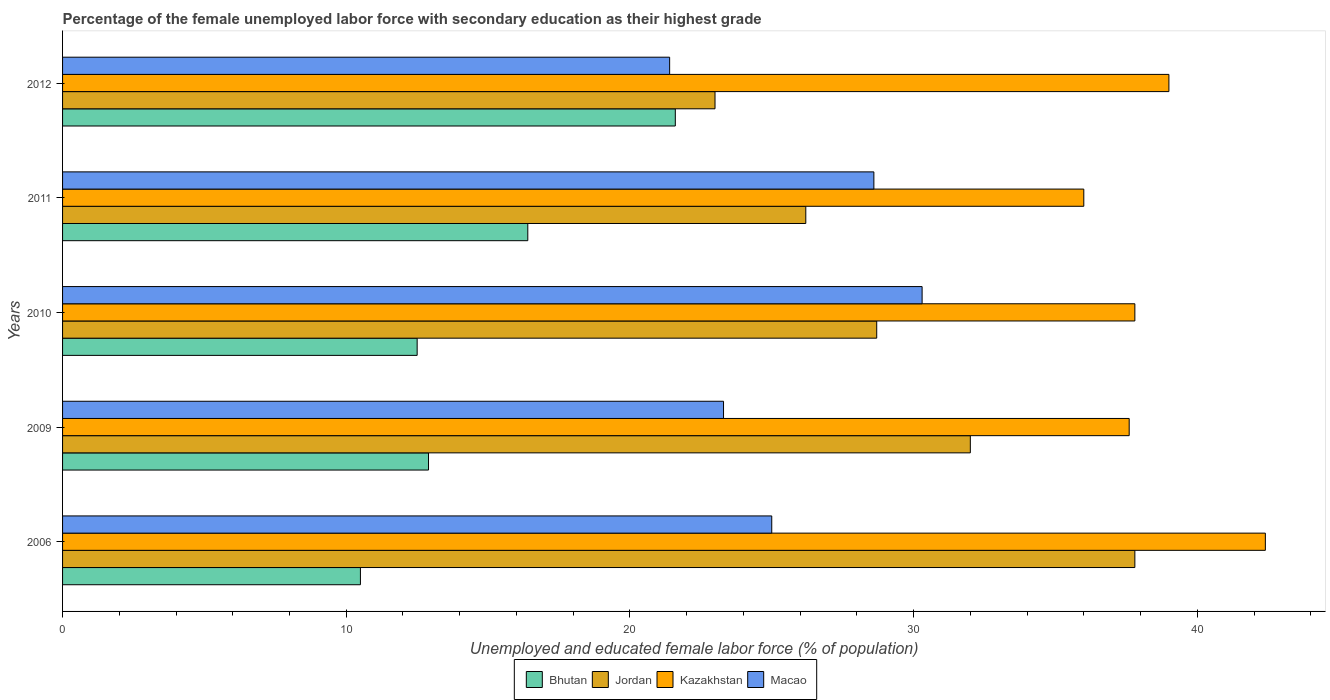How many different coloured bars are there?
Your response must be concise. 4. Are the number of bars on each tick of the Y-axis equal?
Provide a succinct answer. Yes. How many bars are there on the 2nd tick from the bottom?
Ensure brevity in your answer.  4. What is the percentage of the unemployed female labor force with secondary education in Bhutan in 2009?
Keep it short and to the point. 12.9. Across all years, what is the maximum percentage of the unemployed female labor force with secondary education in Kazakhstan?
Give a very brief answer. 42.4. Across all years, what is the minimum percentage of the unemployed female labor force with secondary education in Jordan?
Your answer should be compact. 23. In which year was the percentage of the unemployed female labor force with secondary education in Bhutan maximum?
Your response must be concise. 2012. What is the total percentage of the unemployed female labor force with secondary education in Kazakhstan in the graph?
Offer a very short reply. 192.8. What is the difference between the percentage of the unemployed female labor force with secondary education in Kazakhstan in 2006 and that in 2010?
Give a very brief answer. 4.6. What is the difference between the percentage of the unemployed female labor force with secondary education in Bhutan in 2006 and the percentage of the unemployed female labor force with secondary education in Jordan in 2011?
Your response must be concise. -15.7. What is the average percentage of the unemployed female labor force with secondary education in Bhutan per year?
Ensure brevity in your answer.  14.78. In how many years, is the percentage of the unemployed female labor force with secondary education in Jordan greater than 18 %?
Keep it short and to the point. 5. What is the ratio of the percentage of the unemployed female labor force with secondary education in Kazakhstan in 2006 to that in 2012?
Offer a very short reply. 1.09. Is the difference between the percentage of the unemployed female labor force with secondary education in Macao in 2010 and 2012 greater than the difference between the percentage of the unemployed female labor force with secondary education in Bhutan in 2010 and 2012?
Your answer should be compact. Yes. What is the difference between the highest and the second highest percentage of the unemployed female labor force with secondary education in Kazakhstan?
Give a very brief answer. 3.4. What is the difference between the highest and the lowest percentage of the unemployed female labor force with secondary education in Bhutan?
Provide a short and direct response. 11.1. What does the 3rd bar from the top in 2009 represents?
Offer a terse response. Jordan. What does the 3rd bar from the bottom in 2012 represents?
Ensure brevity in your answer.  Kazakhstan. Is it the case that in every year, the sum of the percentage of the unemployed female labor force with secondary education in Bhutan and percentage of the unemployed female labor force with secondary education in Macao is greater than the percentage of the unemployed female labor force with secondary education in Kazakhstan?
Keep it short and to the point. No. How many bars are there?
Offer a terse response. 20. Are all the bars in the graph horizontal?
Your answer should be compact. Yes. What is the difference between two consecutive major ticks on the X-axis?
Keep it short and to the point. 10. Does the graph contain any zero values?
Provide a succinct answer. No. How many legend labels are there?
Your response must be concise. 4. What is the title of the graph?
Ensure brevity in your answer.  Percentage of the female unemployed labor force with secondary education as their highest grade. What is the label or title of the X-axis?
Provide a succinct answer. Unemployed and educated female labor force (% of population). What is the Unemployed and educated female labor force (% of population) in Bhutan in 2006?
Keep it short and to the point. 10.5. What is the Unemployed and educated female labor force (% of population) of Jordan in 2006?
Offer a very short reply. 37.8. What is the Unemployed and educated female labor force (% of population) of Kazakhstan in 2006?
Ensure brevity in your answer.  42.4. What is the Unemployed and educated female labor force (% of population) of Macao in 2006?
Keep it short and to the point. 25. What is the Unemployed and educated female labor force (% of population) in Bhutan in 2009?
Your answer should be very brief. 12.9. What is the Unemployed and educated female labor force (% of population) in Jordan in 2009?
Your response must be concise. 32. What is the Unemployed and educated female labor force (% of population) in Kazakhstan in 2009?
Give a very brief answer. 37.6. What is the Unemployed and educated female labor force (% of population) of Macao in 2009?
Your answer should be very brief. 23.3. What is the Unemployed and educated female labor force (% of population) in Jordan in 2010?
Provide a succinct answer. 28.7. What is the Unemployed and educated female labor force (% of population) in Kazakhstan in 2010?
Make the answer very short. 37.8. What is the Unemployed and educated female labor force (% of population) of Macao in 2010?
Make the answer very short. 30.3. What is the Unemployed and educated female labor force (% of population) of Bhutan in 2011?
Offer a terse response. 16.4. What is the Unemployed and educated female labor force (% of population) of Jordan in 2011?
Give a very brief answer. 26.2. What is the Unemployed and educated female labor force (% of population) of Kazakhstan in 2011?
Make the answer very short. 36. What is the Unemployed and educated female labor force (% of population) of Macao in 2011?
Offer a terse response. 28.6. What is the Unemployed and educated female labor force (% of population) in Bhutan in 2012?
Provide a succinct answer. 21.6. What is the Unemployed and educated female labor force (% of population) of Macao in 2012?
Give a very brief answer. 21.4. Across all years, what is the maximum Unemployed and educated female labor force (% of population) of Bhutan?
Your answer should be compact. 21.6. Across all years, what is the maximum Unemployed and educated female labor force (% of population) in Jordan?
Make the answer very short. 37.8. Across all years, what is the maximum Unemployed and educated female labor force (% of population) in Kazakhstan?
Keep it short and to the point. 42.4. Across all years, what is the maximum Unemployed and educated female labor force (% of population) of Macao?
Provide a short and direct response. 30.3. Across all years, what is the minimum Unemployed and educated female labor force (% of population) in Jordan?
Ensure brevity in your answer.  23. Across all years, what is the minimum Unemployed and educated female labor force (% of population) of Macao?
Your answer should be compact. 21.4. What is the total Unemployed and educated female labor force (% of population) of Bhutan in the graph?
Provide a succinct answer. 73.9. What is the total Unemployed and educated female labor force (% of population) of Jordan in the graph?
Ensure brevity in your answer.  147.7. What is the total Unemployed and educated female labor force (% of population) in Kazakhstan in the graph?
Give a very brief answer. 192.8. What is the total Unemployed and educated female labor force (% of population) of Macao in the graph?
Make the answer very short. 128.6. What is the difference between the Unemployed and educated female labor force (% of population) of Bhutan in 2006 and that in 2009?
Your answer should be compact. -2.4. What is the difference between the Unemployed and educated female labor force (% of population) in Macao in 2006 and that in 2009?
Provide a short and direct response. 1.7. What is the difference between the Unemployed and educated female labor force (% of population) of Macao in 2006 and that in 2011?
Provide a short and direct response. -3.6. What is the difference between the Unemployed and educated female labor force (% of population) of Bhutan in 2006 and that in 2012?
Keep it short and to the point. -11.1. What is the difference between the Unemployed and educated female labor force (% of population) of Kazakhstan in 2006 and that in 2012?
Give a very brief answer. 3.4. What is the difference between the Unemployed and educated female labor force (% of population) in Macao in 2006 and that in 2012?
Ensure brevity in your answer.  3.6. What is the difference between the Unemployed and educated female labor force (% of population) of Jordan in 2009 and that in 2010?
Make the answer very short. 3.3. What is the difference between the Unemployed and educated female labor force (% of population) in Kazakhstan in 2009 and that in 2010?
Your answer should be compact. -0.2. What is the difference between the Unemployed and educated female labor force (% of population) in Jordan in 2009 and that in 2011?
Your answer should be compact. 5.8. What is the difference between the Unemployed and educated female labor force (% of population) of Macao in 2009 and that in 2011?
Make the answer very short. -5.3. What is the difference between the Unemployed and educated female labor force (% of population) of Kazakhstan in 2009 and that in 2012?
Offer a terse response. -1.4. What is the difference between the Unemployed and educated female labor force (% of population) of Macao in 2009 and that in 2012?
Ensure brevity in your answer.  1.9. What is the difference between the Unemployed and educated female labor force (% of population) in Jordan in 2010 and that in 2011?
Your answer should be compact. 2.5. What is the difference between the Unemployed and educated female labor force (% of population) of Kazakhstan in 2010 and that in 2011?
Offer a very short reply. 1.8. What is the difference between the Unemployed and educated female labor force (% of population) in Macao in 2010 and that in 2011?
Give a very brief answer. 1.7. What is the difference between the Unemployed and educated female labor force (% of population) of Macao in 2010 and that in 2012?
Your answer should be very brief. 8.9. What is the difference between the Unemployed and educated female labor force (% of population) of Jordan in 2011 and that in 2012?
Give a very brief answer. 3.2. What is the difference between the Unemployed and educated female labor force (% of population) in Macao in 2011 and that in 2012?
Keep it short and to the point. 7.2. What is the difference between the Unemployed and educated female labor force (% of population) in Bhutan in 2006 and the Unemployed and educated female labor force (% of population) in Jordan in 2009?
Provide a succinct answer. -21.5. What is the difference between the Unemployed and educated female labor force (% of population) in Bhutan in 2006 and the Unemployed and educated female labor force (% of population) in Kazakhstan in 2009?
Keep it short and to the point. -27.1. What is the difference between the Unemployed and educated female labor force (% of population) in Bhutan in 2006 and the Unemployed and educated female labor force (% of population) in Macao in 2009?
Your response must be concise. -12.8. What is the difference between the Unemployed and educated female labor force (% of population) in Jordan in 2006 and the Unemployed and educated female labor force (% of population) in Kazakhstan in 2009?
Ensure brevity in your answer.  0.2. What is the difference between the Unemployed and educated female labor force (% of population) in Jordan in 2006 and the Unemployed and educated female labor force (% of population) in Macao in 2009?
Your response must be concise. 14.5. What is the difference between the Unemployed and educated female labor force (% of population) in Bhutan in 2006 and the Unemployed and educated female labor force (% of population) in Jordan in 2010?
Keep it short and to the point. -18.2. What is the difference between the Unemployed and educated female labor force (% of population) in Bhutan in 2006 and the Unemployed and educated female labor force (% of population) in Kazakhstan in 2010?
Keep it short and to the point. -27.3. What is the difference between the Unemployed and educated female labor force (% of population) of Bhutan in 2006 and the Unemployed and educated female labor force (% of population) of Macao in 2010?
Your answer should be very brief. -19.8. What is the difference between the Unemployed and educated female labor force (% of population) in Jordan in 2006 and the Unemployed and educated female labor force (% of population) in Kazakhstan in 2010?
Offer a terse response. 0. What is the difference between the Unemployed and educated female labor force (% of population) of Jordan in 2006 and the Unemployed and educated female labor force (% of population) of Macao in 2010?
Your response must be concise. 7.5. What is the difference between the Unemployed and educated female labor force (% of population) of Kazakhstan in 2006 and the Unemployed and educated female labor force (% of population) of Macao in 2010?
Your answer should be compact. 12.1. What is the difference between the Unemployed and educated female labor force (% of population) in Bhutan in 2006 and the Unemployed and educated female labor force (% of population) in Jordan in 2011?
Your answer should be compact. -15.7. What is the difference between the Unemployed and educated female labor force (% of population) in Bhutan in 2006 and the Unemployed and educated female labor force (% of population) in Kazakhstan in 2011?
Your answer should be compact. -25.5. What is the difference between the Unemployed and educated female labor force (% of population) in Bhutan in 2006 and the Unemployed and educated female labor force (% of population) in Macao in 2011?
Provide a short and direct response. -18.1. What is the difference between the Unemployed and educated female labor force (% of population) in Jordan in 2006 and the Unemployed and educated female labor force (% of population) in Kazakhstan in 2011?
Provide a succinct answer. 1.8. What is the difference between the Unemployed and educated female labor force (% of population) of Jordan in 2006 and the Unemployed and educated female labor force (% of population) of Macao in 2011?
Offer a terse response. 9.2. What is the difference between the Unemployed and educated female labor force (% of population) of Bhutan in 2006 and the Unemployed and educated female labor force (% of population) of Jordan in 2012?
Keep it short and to the point. -12.5. What is the difference between the Unemployed and educated female labor force (% of population) in Bhutan in 2006 and the Unemployed and educated female labor force (% of population) in Kazakhstan in 2012?
Your answer should be very brief. -28.5. What is the difference between the Unemployed and educated female labor force (% of population) of Jordan in 2006 and the Unemployed and educated female labor force (% of population) of Kazakhstan in 2012?
Your answer should be very brief. -1.2. What is the difference between the Unemployed and educated female labor force (% of population) in Kazakhstan in 2006 and the Unemployed and educated female labor force (% of population) in Macao in 2012?
Provide a short and direct response. 21. What is the difference between the Unemployed and educated female labor force (% of population) in Bhutan in 2009 and the Unemployed and educated female labor force (% of population) in Jordan in 2010?
Offer a very short reply. -15.8. What is the difference between the Unemployed and educated female labor force (% of population) in Bhutan in 2009 and the Unemployed and educated female labor force (% of population) in Kazakhstan in 2010?
Ensure brevity in your answer.  -24.9. What is the difference between the Unemployed and educated female labor force (% of population) of Bhutan in 2009 and the Unemployed and educated female labor force (% of population) of Macao in 2010?
Ensure brevity in your answer.  -17.4. What is the difference between the Unemployed and educated female labor force (% of population) in Jordan in 2009 and the Unemployed and educated female labor force (% of population) in Kazakhstan in 2010?
Give a very brief answer. -5.8. What is the difference between the Unemployed and educated female labor force (% of population) in Jordan in 2009 and the Unemployed and educated female labor force (% of population) in Macao in 2010?
Make the answer very short. 1.7. What is the difference between the Unemployed and educated female labor force (% of population) in Bhutan in 2009 and the Unemployed and educated female labor force (% of population) in Kazakhstan in 2011?
Offer a terse response. -23.1. What is the difference between the Unemployed and educated female labor force (% of population) of Bhutan in 2009 and the Unemployed and educated female labor force (% of population) of Macao in 2011?
Offer a terse response. -15.7. What is the difference between the Unemployed and educated female labor force (% of population) of Jordan in 2009 and the Unemployed and educated female labor force (% of population) of Macao in 2011?
Offer a terse response. 3.4. What is the difference between the Unemployed and educated female labor force (% of population) in Bhutan in 2009 and the Unemployed and educated female labor force (% of population) in Jordan in 2012?
Your answer should be compact. -10.1. What is the difference between the Unemployed and educated female labor force (% of population) of Bhutan in 2009 and the Unemployed and educated female labor force (% of population) of Kazakhstan in 2012?
Keep it short and to the point. -26.1. What is the difference between the Unemployed and educated female labor force (% of population) of Jordan in 2009 and the Unemployed and educated female labor force (% of population) of Kazakhstan in 2012?
Offer a very short reply. -7. What is the difference between the Unemployed and educated female labor force (% of population) of Kazakhstan in 2009 and the Unemployed and educated female labor force (% of population) of Macao in 2012?
Give a very brief answer. 16.2. What is the difference between the Unemployed and educated female labor force (% of population) in Bhutan in 2010 and the Unemployed and educated female labor force (% of population) in Jordan in 2011?
Offer a terse response. -13.7. What is the difference between the Unemployed and educated female labor force (% of population) in Bhutan in 2010 and the Unemployed and educated female labor force (% of population) in Kazakhstan in 2011?
Offer a very short reply. -23.5. What is the difference between the Unemployed and educated female labor force (% of population) in Bhutan in 2010 and the Unemployed and educated female labor force (% of population) in Macao in 2011?
Give a very brief answer. -16.1. What is the difference between the Unemployed and educated female labor force (% of population) in Kazakhstan in 2010 and the Unemployed and educated female labor force (% of population) in Macao in 2011?
Your response must be concise. 9.2. What is the difference between the Unemployed and educated female labor force (% of population) in Bhutan in 2010 and the Unemployed and educated female labor force (% of population) in Kazakhstan in 2012?
Provide a short and direct response. -26.5. What is the difference between the Unemployed and educated female labor force (% of population) of Bhutan in 2011 and the Unemployed and educated female labor force (% of population) of Jordan in 2012?
Offer a very short reply. -6.6. What is the difference between the Unemployed and educated female labor force (% of population) in Bhutan in 2011 and the Unemployed and educated female labor force (% of population) in Kazakhstan in 2012?
Your answer should be compact. -22.6. What is the difference between the Unemployed and educated female labor force (% of population) in Bhutan in 2011 and the Unemployed and educated female labor force (% of population) in Macao in 2012?
Your response must be concise. -5. What is the difference between the Unemployed and educated female labor force (% of population) in Jordan in 2011 and the Unemployed and educated female labor force (% of population) in Macao in 2012?
Your answer should be compact. 4.8. What is the average Unemployed and educated female labor force (% of population) in Bhutan per year?
Give a very brief answer. 14.78. What is the average Unemployed and educated female labor force (% of population) in Jordan per year?
Keep it short and to the point. 29.54. What is the average Unemployed and educated female labor force (% of population) in Kazakhstan per year?
Provide a short and direct response. 38.56. What is the average Unemployed and educated female labor force (% of population) in Macao per year?
Offer a terse response. 25.72. In the year 2006, what is the difference between the Unemployed and educated female labor force (% of population) in Bhutan and Unemployed and educated female labor force (% of population) in Jordan?
Your answer should be very brief. -27.3. In the year 2006, what is the difference between the Unemployed and educated female labor force (% of population) of Bhutan and Unemployed and educated female labor force (% of population) of Kazakhstan?
Give a very brief answer. -31.9. In the year 2006, what is the difference between the Unemployed and educated female labor force (% of population) of Bhutan and Unemployed and educated female labor force (% of population) of Macao?
Ensure brevity in your answer.  -14.5. In the year 2006, what is the difference between the Unemployed and educated female labor force (% of population) in Jordan and Unemployed and educated female labor force (% of population) in Macao?
Your answer should be compact. 12.8. In the year 2006, what is the difference between the Unemployed and educated female labor force (% of population) in Kazakhstan and Unemployed and educated female labor force (% of population) in Macao?
Offer a terse response. 17.4. In the year 2009, what is the difference between the Unemployed and educated female labor force (% of population) in Bhutan and Unemployed and educated female labor force (% of population) in Jordan?
Provide a succinct answer. -19.1. In the year 2009, what is the difference between the Unemployed and educated female labor force (% of population) in Bhutan and Unemployed and educated female labor force (% of population) in Kazakhstan?
Your answer should be very brief. -24.7. In the year 2009, what is the difference between the Unemployed and educated female labor force (% of population) of Jordan and Unemployed and educated female labor force (% of population) of Macao?
Your response must be concise. 8.7. In the year 2010, what is the difference between the Unemployed and educated female labor force (% of population) in Bhutan and Unemployed and educated female labor force (% of population) in Jordan?
Give a very brief answer. -16.2. In the year 2010, what is the difference between the Unemployed and educated female labor force (% of population) in Bhutan and Unemployed and educated female labor force (% of population) in Kazakhstan?
Offer a terse response. -25.3. In the year 2010, what is the difference between the Unemployed and educated female labor force (% of population) in Bhutan and Unemployed and educated female labor force (% of population) in Macao?
Your response must be concise. -17.8. In the year 2010, what is the difference between the Unemployed and educated female labor force (% of population) in Jordan and Unemployed and educated female labor force (% of population) in Kazakhstan?
Your answer should be very brief. -9.1. In the year 2010, what is the difference between the Unemployed and educated female labor force (% of population) of Jordan and Unemployed and educated female labor force (% of population) of Macao?
Ensure brevity in your answer.  -1.6. In the year 2011, what is the difference between the Unemployed and educated female labor force (% of population) in Bhutan and Unemployed and educated female labor force (% of population) in Jordan?
Provide a short and direct response. -9.8. In the year 2011, what is the difference between the Unemployed and educated female labor force (% of population) of Bhutan and Unemployed and educated female labor force (% of population) of Kazakhstan?
Offer a very short reply. -19.6. In the year 2011, what is the difference between the Unemployed and educated female labor force (% of population) in Jordan and Unemployed and educated female labor force (% of population) in Macao?
Your response must be concise. -2.4. In the year 2012, what is the difference between the Unemployed and educated female labor force (% of population) in Bhutan and Unemployed and educated female labor force (% of population) in Jordan?
Ensure brevity in your answer.  -1.4. In the year 2012, what is the difference between the Unemployed and educated female labor force (% of population) of Bhutan and Unemployed and educated female labor force (% of population) of Kazakhstan?
Your answer should be compact. -17.4. In the year 2012, what is the difference between the Unemployed and educated female labor force (% of population) in Bhutan and Unemployed and educated female labor force (% of population) in Macao?
Provide a short and direct response. 0.2. In the year 2012, what is the difference between the Unemployed and educated female labor force (% of population) in Jordan and Unemployed and educated female labor force (% of population) in Kazakhstan?
Your answer should be compact. -16. In the year 2012, what is the difference between the Unemployed and educated female labor force (% of population) of Jordan and Unemployed and educated female labor force (% of population) of Macao?
Provide a short and direct response. 1.6. In the year 2012, what is the difference between the Unemployed and educated female labor force (% of population) of Kazakhstan and Unemployed and educated female labor force (% of population) of Macao?
Offer a very short reply. 17.6. What is the ratio of the Unemployed and educated female labor force (% of population) of Bhutan in 2006 to that in 2009?
Your response must be concise. 0.81. What is the ratio of the Unemployed and educated female labor force (% of population) of Jordan in 2006 to that in 2009?
Give a very brief answer. 1.18. What is the ratio of the Unemployed and educated female labor force (% of population) in Kazakhstan in 2006 to that in 2009?
Offer a terse response. 1.13. What is the ratio of the Unemployed and educated female labor force (% of population) in Macao in 2006 to that in 2009?
Provide a short and direct response. 1.07. What is the ratio of the Unemployed and educated female labor force (% of population) of Bhutan in 2006 to that in 2010?
Keep it short and to the point. 0.84. What is the ratio of the Unemployed and educated female labor force (% of population) in Jordan in 2006 to that in 2010?
Your response must be concise. 1.32. What is the ratio of the Unemployed and educated female labor force (% of population) in Kazakhstan in 2006 to that in 2010?
Ensure brevity in your answer.  1.12. What is the ratio of the Unemployed and educated female labor force (% of population) of Macao in 2006 to that in 2010?
Your answer should be compact. 0.83. What is the ratio of the Unemployed and educated female labor force (% of population) in Bhutan in 2006 to that in 2011?
Your answer should be compact. 0.64. What is the ratio of the Unemployed and educated female labor force (% of population) of Jordan in 2006 to that in 2011?
Your answer should be very brief. 1.44. What is the ratio of the Unemployed and educated female labor force (% of population) of Kazakhstan in 2006 to that in 2011?
Offer a very short reply. 1.18. What is the ratio of the Unemployed and educated female labor force (% of population) of Macao in 2006 to that in 2011?
Keep it short and to the point. 0.87. What is the ratio of the Unemployed and educated female labor force (% of population) of Bhutan in 2006 to that in 2012?
Offer a terse response. 0.49. What is the ratio of the Unemployed and educated female labor force (% of population) in Jordan in 2006 to that in 2012?
Your answer should be compact. 1.64. What is the ratio of the Unemployed and educated female labor force (% of population) of Kazakhstan in 2006 to that in 2012?
Your answer should be compact. 1.09. What is the ratio of the Unemployed and educated female labor force (% of population) in Macao in 2006 to that in 2012?
Offer a terse response. 1.17. What is the ratio of the Unemployed and educated female labor force (% of population) in Bhutan in 2009 to that in 2010?
Your answer should be compact. 1.03. What is the ratio of the Unemployed and educated female labor force (% of population) of Jordan in 2009 to that in 2010?
Offer a terse response. 1.11. What is the ratio of the Unemployed and educated female labor force (% of population) of Macao in 2009 to that in 2010?
Keep it short and to the point. 0.77. What is the ratio of the Unemployed and educated female labor force (% of population) of Bhutan in 2009 to that in 2011?
Make the answer very short. 0.79. What is the ratio of the Unemployed and educated female labor force (% of population) of Jordan in 2009 to that in 2011?
Provide a succinct answer. 1.22. What is the ratio of the Unemployed and educated female labor force (% of population) of Kazakhstan in 2009 to that in 2011?
Give a very brief answer. 1.04. What is the ratio of the Unemployed and educated female labor force (% of population) in Macao in 2009 to that in 2011?
Your answer should be compact. 0.81. What is the ratio of the Unemployed and educated female labor force (% of population) of Bhutan in 2009 to that in 2012?
Give a very brief answer. 0.6. What is the ratio of the Unemployed and educated female labor force (% of population) in Jordan in 2009 to that in 2012?
Offer a very short reply. 1.39. What is the ratio of the Unemployed and educated female labor force (% of population) of Kazakhstan in 2009 to that in 2012?
Your answer should be very brief. 0.96. What is the ratio of the Unemployed and educated female labor force (% of population) of Macao in 2009 to that in 2012?
Provide a succinct answer. 1.09. What is the ratio of the Unemployed and educated female labor force (% of population) of Bhutan in 2010 to that in 2011?
Your response must be concise. 0.76. What is the ratio of the Unemployed and educated female labor force (% of population) in Jordan in 2010 to that in 2011?
Provide a short and direct response. 1.1. What is the ratio of the Unemployed and educated female labor force (% of population) in Kazakhstan in 2010 to that in 2011?
Your answer should be compact. 1.05. What is the ratio of the Unemployed and educated female labor force (% of population) of Macao in 2010 to that in 2011?
Offer a terse response. 1.06. What is the ratio of the Unemployed and educated female labor force (% of population) of Bhutan in 2010 to that in 2012?
Provide a succinct answer. 0.58. What is the ratio of the Unemployed and educated female labor force (% of population) in Jordan in 2010 to that in 2012?
Keep it short and to the point. 1.25. What is the ratio of the Unemployed and educated female labor force (% of population) of Kazakhstan in 2010 to that in 2012?
Your answer should be compact. 0.97. What is the ratio of the Unemployed and educated female labor force (% of population) of Macao in 2010 to that in 2012?
Offer a very short reply. 1.42. What is the ratio of the Unemployed and educated female labor force (% of population) of Bhutan in 2011 to that in 2012?
Give a very brief answer. 0.76. What is the ratio of the Unemployed and educated female labor force (% of population) of Jordan in 2011 to that in 2012?
Your response must be concise. 1.14. What is the ratio of the Unemployed and educated female labor force (% of population) in Kazakhstan in 2011 to that in 2012?
Your answer should be very brief. 0.92. What is the ratio of the Unemployed and educated female labor force (% of population) of Macao in 2011 to that in 2012?
Offer a terse response. 1.34. What is the difference between the highest and the second highest Unemployed and educated female labor force (% of population) of Bhutan?
Provide a short and direct response. 5.2. What is the difference between the highest and the second highest Unemployed and educated female labor force (% of population) in Jordan?
Offer a very short reply. 5.8. What is the difference between the highest and the second highest Unemployed and educated female labor force (% of population) in Kazakhstan?
Give a very brief answer. 3.4. What is the difference between the highest and the second highest Unemployed and educated female labor force (% of population) of Macao?
Give a very brief answer. 1.7. What is the difference between the highest and the lowest Unemployed and educated female labor force (% of population) in Bhutan?
Give a very brief answer. 11.1. What is the difference between the highest and the lowest Unemployed and educated female labor force (% of population) in Jordan?
Offer a very short reply. 14.8. What is the difference between the highest and the lowest Unemployed and educated female labor force (% of population) of Kazakhstan?
Your answer should be very brief. 6.4. What is the difference between the highest and the lowest Unemployed and educated female labor force (% of population) in Macao?
Make the answer very short. 8.9. 